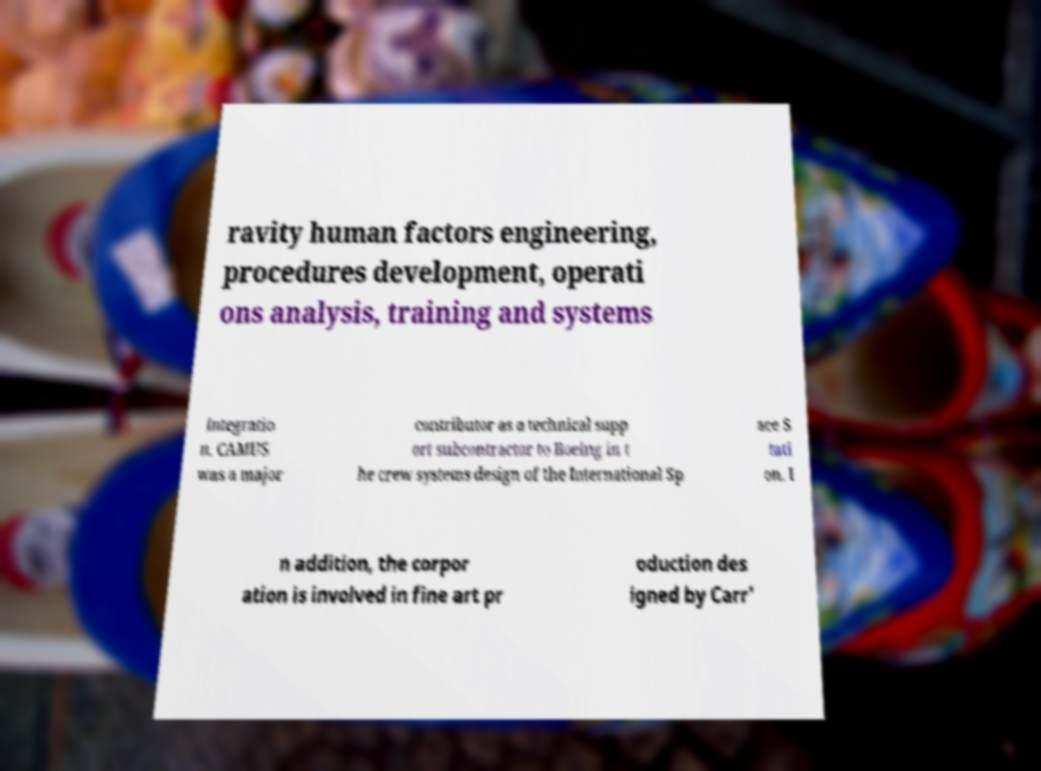Please identify and transcribe the text found in this image. ravity human factors engineering, procedures development, operati ons analysis, training and systems integratio n. CAMUS was a major contributor as a technical supp ort subcontractor to Boeing in t he crew systems design of the International Sp ace S tati on. I n addition, the corpor ation is involved in fine art pr oduction des igned by Carr' 